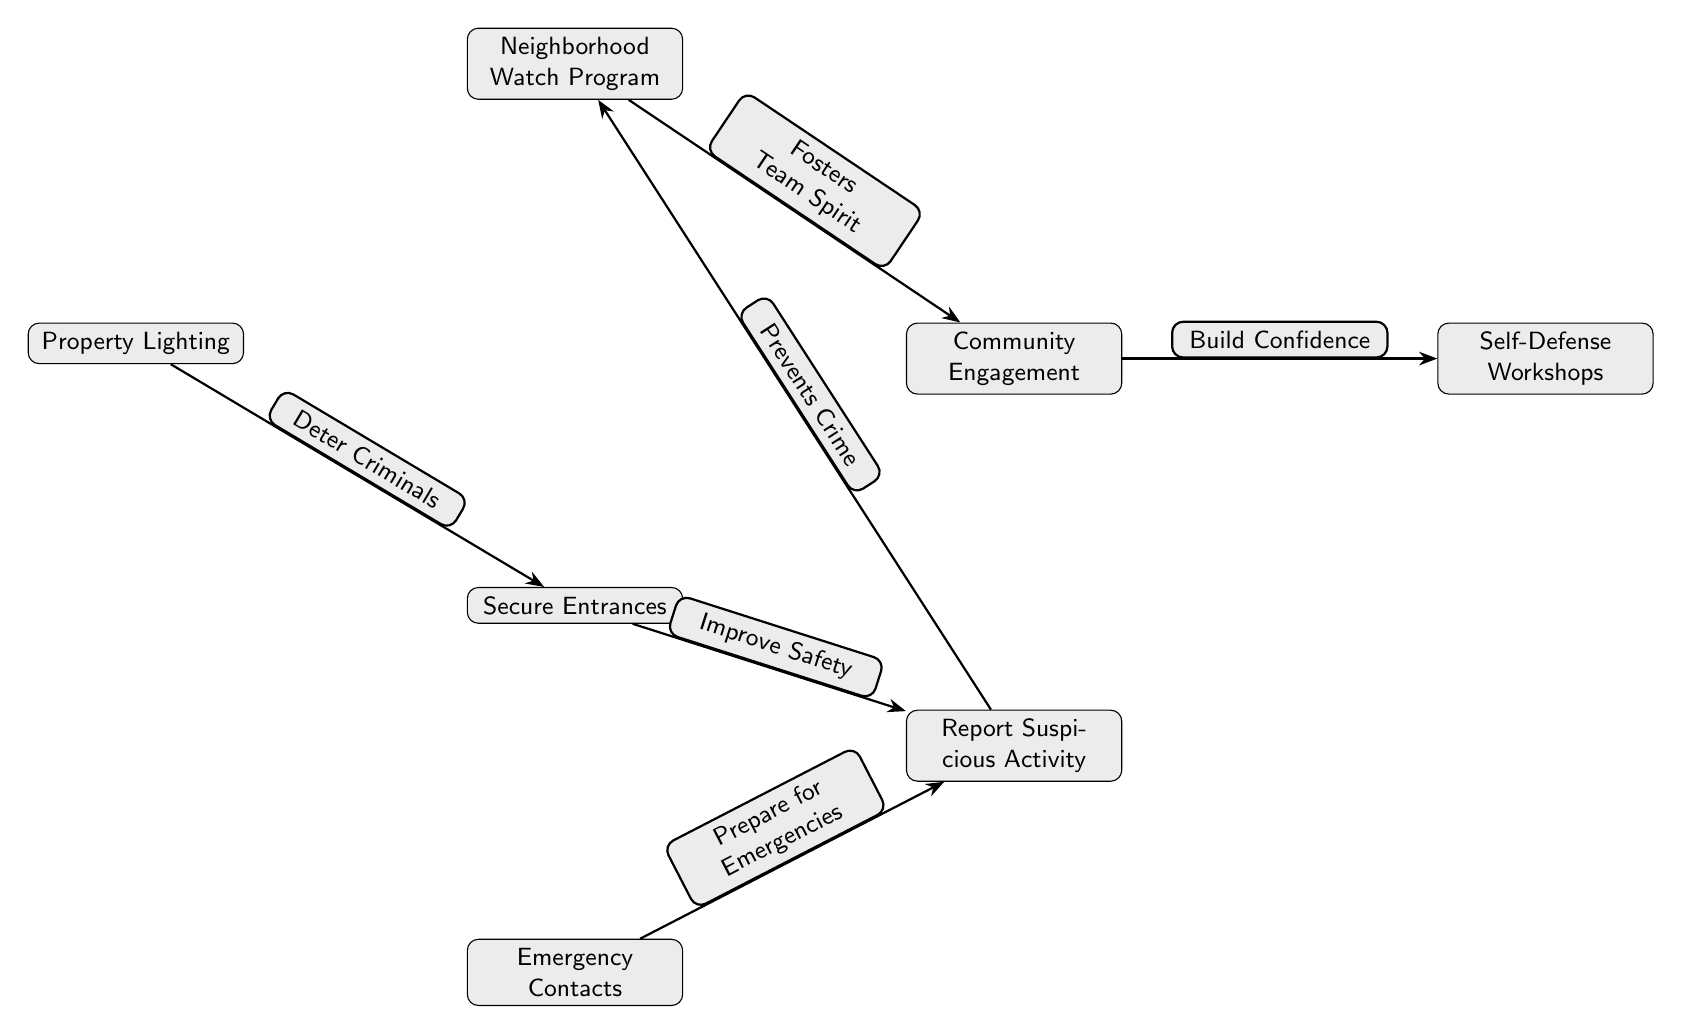What is the top node in the diagram? The top node is labeled as "Neighborhood Watch Program," which is positioned at the highest point in the diagram, indicating its primary role in organizing crime prevention strategies.
Answer: Neighborhood Watch Program How many total nodes are present in the diagram? By counting all the individual components visible in the diagram, we see there are seven nodes representing different strategies for neighborhood crime prevention.
Answer: 7 What connection does "Property Lighting" have with "Secure Entrances"? The edge connecting "Property Lighting" to "Secure Entrances" is labeled "Deter Criminals," suggesting that better property lighting contributes to more secure entrances by discouraging criminal activity.
Answer: Deter Criminals Which two nodes are connected by the label "Build Confidence"? The nodes connected by the label "Build Confidence" are "Community Engagement" and "Self-Defense Workshops," indicating that engaging the community fosters confidence through workshops.
Answer: Community Engagement and Self-Defense Workshops What node is positioned below "Emergency Contacts"? The node directly below "Emergency Contacts" is labeled "Report Suspicious Activity," indicating that having emergency contacts leads to reporting suspicious occurrences in the neighborhood.
Answer: Report Suspicious Activity Which node leads to "Prevents Crime"? The node that leads to "Prevents Crime" as per the directed edge is labeled "Report Suspicious Activity," highlighting its effectiveness in crime prevention when residents stay vigilant.
Answer: Report Suspicious Activity What is the relationship between "Secure Entrances" and "Emergency Contacts"? "Secure Entrances" improves safety, which connects to "Emergency Contacts" by making it easier to prepare for emergencies, showing the importance of good entry security.
Answer: Improve Safety What is the significance of the label on the edge leading from "Neighborhood Watch Program" to "Community Engagement"? The label on the edge "Fosters Team Spirit" signifies that engaging with the community through a neighborhood watch helps build a collaborative environment focused on safety and support.
Answer: Fosters Team Spirit 